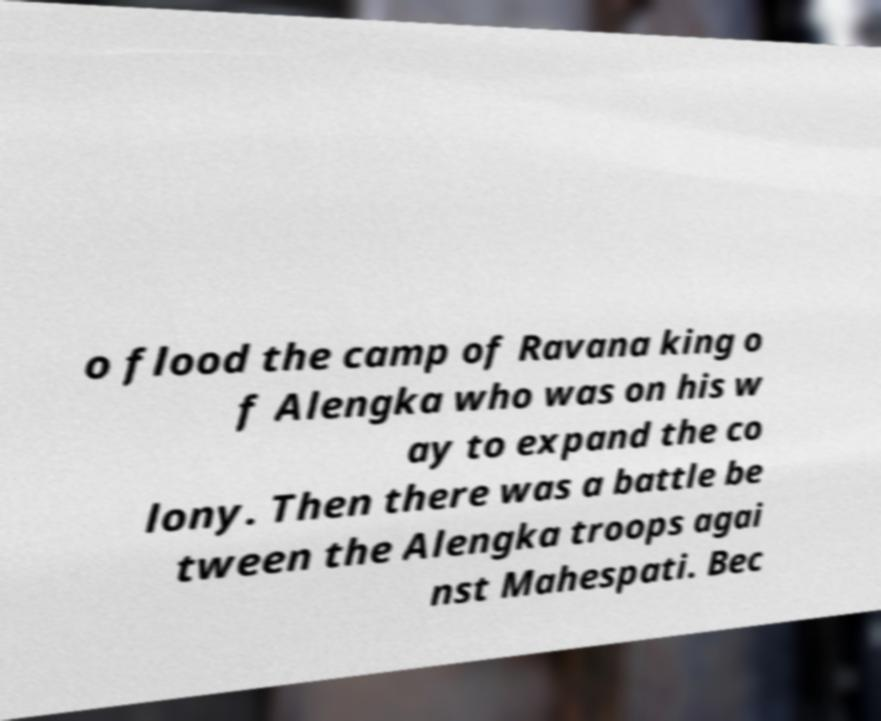What messages or text are displayed in this image? I need them in a readable, typed format. o flood the camp of Ravana king o f Alengka who was on his w ay to expand the co lony. Then there was a battle be tween the Alengka troops agai nst Mahespati. Bec 